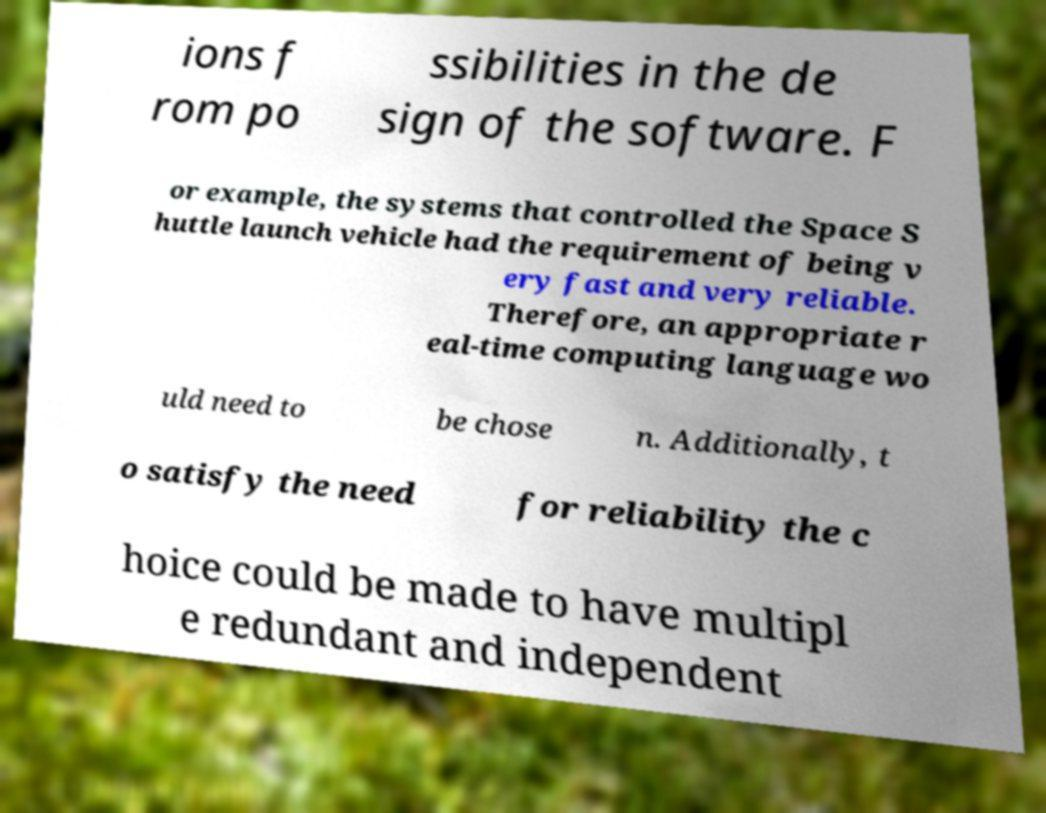There's text embedded in this image that I need extracted. Can you transcribe it verbatim? ions f rom po ssibilities in the de sign of the software. F or example, the systems that controlled the Space S huttle launch vehicle had the requirement of being v ery fast and very reliable. Therefore, an appropriate r eal-time computing language wo uld need to be chose n. Additionally, t o satisfy the need for reliability the c hoice could be made to have multipl e redundant and independent 